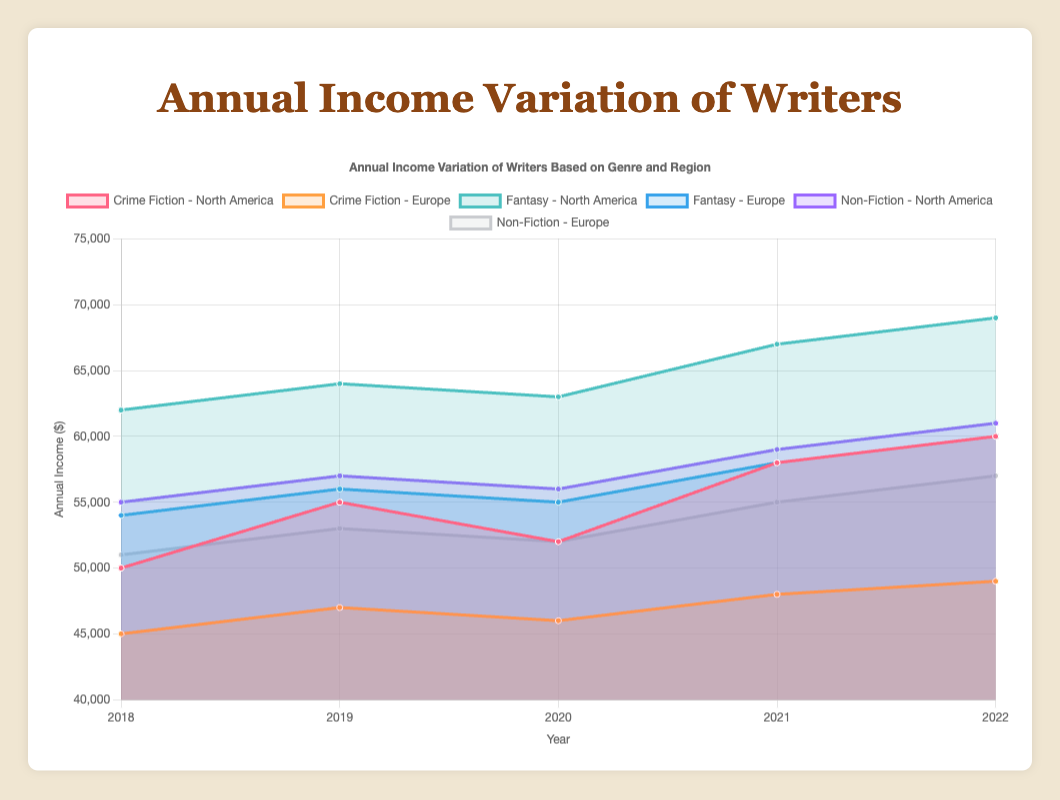What is the title of the chart? The title of the chart can be found at the top of the figure. In this case, it is displayed as "Annual Income Variation of Writers Based on Genre and Region."
Answer: Annual Income Variation of Writers Based on Genre and Region What is the annual income of Crime Fiction writers in North America in 2019? To find this information, you can look at the data points for Crime Fiction writers in North America for the year 2019. The corresponding annual income is stated directly on the chart or in the data used to generate it.
Answer: $55,000 Which genre and region combination had the highest annual income in 2022? By examining the data points for different genres and regions in the year 2022, you can compare their annual incomes. Fantasy writers in North America had the highest annual income in 2022 at $69,000.
Answer: Fantasy - North America How did the annual income of Non-Fiction writers in Europe change from 2019 to 2022? To answer this, look at the annual incomes of Non-Fiction writers in Europe for the years 2019 and 2022. The income changed from $53,000 in 2019 to $57,000 in 2022. The difference is $57,000 - $53,000 = $4,000.
Answer: Increased by $4,000 What is the average annual income of Fantasy writers in North America from 2018 to 2022? To find the average annual income, sum up the annual incomes for Fantasy writers in North America from 2018 to 2022 and then divide by the number of years. The incomes are $62,000, $64,000, $63,000, $67,000, and $69,000. Sum = $62,000 + $64,000 + $63,000 + $67,000 + $69,000 = $325,000. Average = $325,000 / 5 = $65,000.
Answer: $65,000 Compare the trend of annual income for Crime Fiction writers between North America and Europe from 2018 to 2022. To compare the trends, observe the changes in annual incomes over the years 2018 to 2022 for both regions. In North America, the income went from $50,000 in 2018 to $60,000 in 2022, showing a general upward trend. In Europe, it went from $45,000 in 2018 to $49,000 in 2022, also showing an upward trend but at a slower rate.
Answer: Both increased, North America more significantly What was the lowest annual income recorded in the chart, and what genre and region does it correspond to? The lowest annual income can be identified by looking at the smallest data point in the area chart. It belongs to Crime Fiction writers in Europe in 2018 and the amount is $45,000.
Answer: Crime Fiction - Europe, $45,000 What is the most significant change in annual income from one year to the next for Fantasy writers in Europe? To identify the most significant change, you need to calculate the year-to-year differences in annual income for Fantasy writers in Europe. The changes are: 2018 to 2019: $2,000, 2019 to 2020: -$1,000, 2020 to 2021: $3,000, 2021 to 2022: $2,000. The largest change is from 2020 to 2021, with an increase of $3,000.
Answer: $3,000 from 2020 to 2021 How does the annual income of Non-Fiction writers in North America in 2020 compare to that in Europe in the same year? To compare, look at the annual incomes for Non-Fiction writers in both regions in 2020. In North America, the income is $56,000, whereas in Europe, it is $52,000. Therefore, the income is higher in North America by $4,000 in 2020.
Answer: Higher by $4,000 